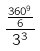<formula> <loc_0><loc_0><loc_500><loc_500>\frac { \frac { 3 6 0 ^ { 9 } } { 6 } } { 3 ^ { 3 } }</formula> 